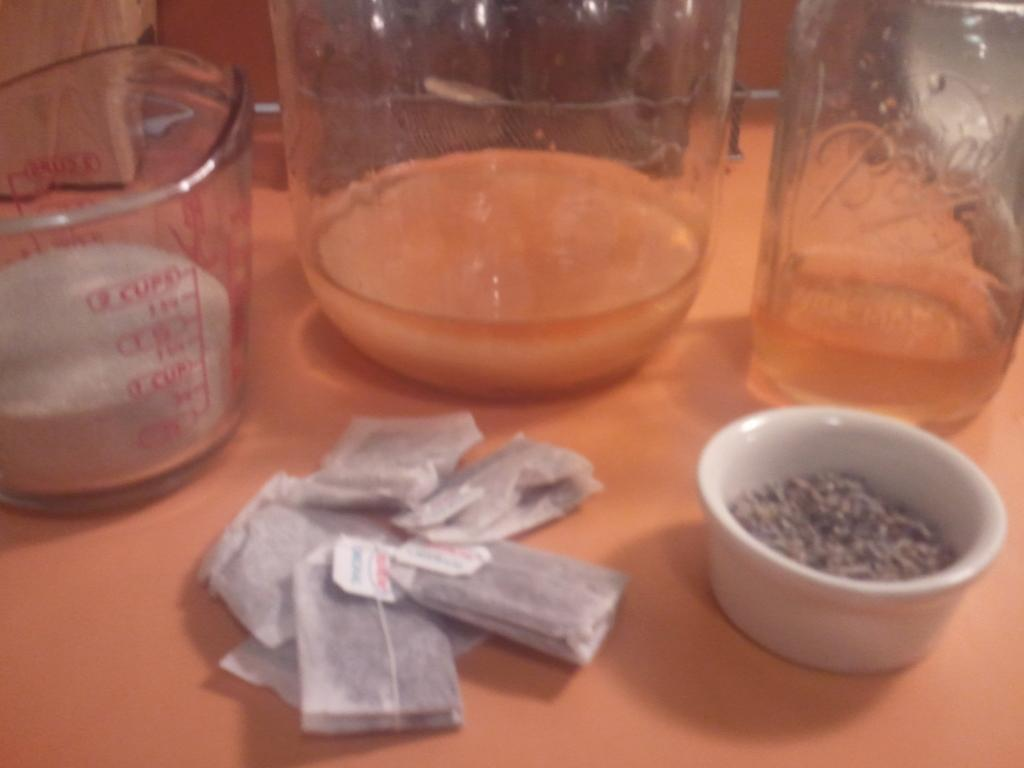<image>
Create a compact narrative representing the image presented. A 2 cup measuring cup sits by tea bags, a small bowl and glass bottles, 